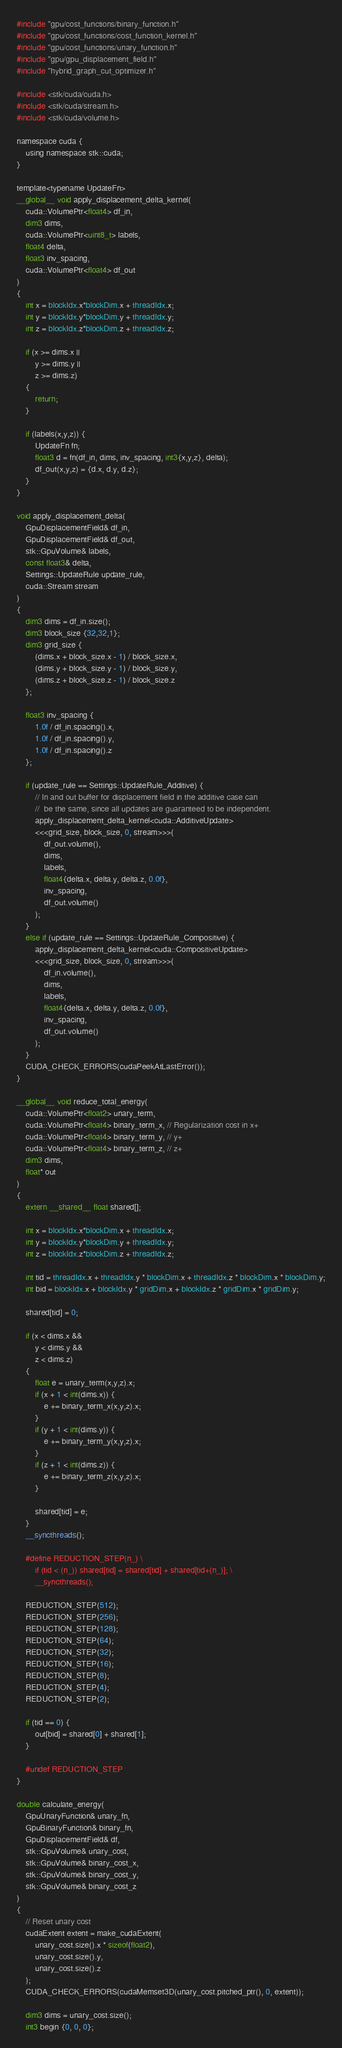Convert code to text. <code><loc_0><loc_0><loc_500><loc_500><_Cuda_>#include "gpu/cost_functions/binary_function.h"
#include "gpu/cost_functions/cost_function_kernel.h"
#include "gpu/cost_functions/unary_function.h"
#include "gpu/gpu_displacement_field.h"
#include "hybrid_graph_cut_optimizer.h"

#include <stk/cuda/cuda.h>
#include <stk/cuda/stream.h>
#include <stk/cuda/volume.h>

namespace cuda {
    using namespace stk::cuda;
}

template<typename UpdateFn>
__global__ void apply_displacement_delta_kernel(
    cuda::VolumePtr<float4> df_in,
    dim3 dims,
    cuda::VolumePtr<uint8_t> labels,
    float4 delta,
    float3 inv_spacing,
    cuda::VolumePtr<float4> df_out
)
{
    int x = blockIdx.x*blockDim.x + threadIdx.x;
    int y = blockIdx.y*blockDim.y + threadIdx.y;
    int z = blockIdx.z*blockDim.z + threadIdx.z;

    if (x >= dims.x ||
        y >= dims.y ||
        z >= dims.z)
    {
        return;
    }

    if (labels(x,y,z)) {
        UpdateFn fn;
        float3 d = fn(df_in, dims, inv_spacing, int3{x,y,z}, delta);
        df_out(x,y,z) = {d.x, d.y, d.z};
    }
}

void apply_displacement_delta(
    GpuDisplacementField& df_in,
    GpuDisplacementField& df_out,
    stk::GpuVolume& labels,
    const float3& delta,
    Settings::UpdateRule update_rule,
    cuda::Stream stream
)
{
    dim3 dims = df_in.size();
    dim3 block_size {32,32,1};
    dim3 grid_size {
        (dims.x + block_size.x - 1) / block_size.x,
        (dims.y + block_size.y - 1) / block_size.y,
        (dims.z + block_size.z - 1) / block_size.z
    };

    float3 inv_spacing {
        1.0f / df_in.spacing().x,
        1.0f / df_in.spacing().y,
        1.0f / df_in.spacing().z
    };

    if (update_rule == Settings::UpdateRule_Additive) {
        // In and out buffer for displacement field in the additive case can 
        //  be the same, since all updates are guaranteed to be independent.
        apply_displacement_delta_kernel<cuda::AdditiveUpdate>
        <<<grid_size, block_size, 0, stream>>>(
            df_out.volume(),
            dims,
            labels,
            float4{delta.x, delta.y, delta.z, 0.0f},
            inv_spacing,
            df_out.volume()
        );
    }
    else if (update_rule == Settings::UpdateRule_Compositive) {
        apply_displacement_delta_kernel<cuda::CompositiveUpdate>
        <<<grid_size, block_size, 0, stream>>>(
            df_in.volume(),
            dims,
            labels,
            float4{delta.x, delta.y, delta.z, 0.0f},
            inv_spacing,
            df_out.volume()
        );
    }
    CUDA_CHECK_ERRORS(cudaPeekAtLastError());
}

__global__ void reduce_total_energy(
    cuda::VolumePtr<float2> unary_term,
    cuda::VolumePtr<float4> binary_term_x, // Regularization cost in x+
    cuda::VolumePtr<float4> binary_term_y, // y+
    cuda::VolumePtr<float4> binary_term_z, // z+
    dim3 dims,
    float* out
)
{
    extern __shared__ float shared[];

    int x = blockIdx.x*blockDim.x + threadIdx.x;
    int y = blockIdx.y*blockDim.y + threadIdx.y;
    int z = blockIdx.z*blockDim.z + threadIdx.z;

    int tid = threadIdx.x + threadIdx.y * blockDim.x + threadIdx.z * blockDim.x * blockDim.y;
    int bid = blockIdx.x + blockIdx.y * gridDim.x + blockIdx.z * gridDim.x * gridDim.y;

    shared[tid] = 0;

    if (x < dims.x &&
        y < dims.y &&
        z < dims.z)
    {
        float e = unary_term(x,y,z).x;
        if (x + 1 < int(dims.x)) {
            e += binary_term_x(x,y,z).x;
        }
        if (y + 1 < int(dims.y)) {
            e += binary_term_y(x,y,z).x;
        }
        if (z + 1 < int(dims.z)) {
            e += binary_term_z(x,y,z).x;
        }

        shared[tid] = e;
    }
    __syncthreads();

    #define REDUCTION_STEP(n_) \
        if (tid < (n_)) shared[tid] = shared[tid] + shared[tid+(n_)]; \
        __syncthreads();

    REDUCTION_STEP(512);
    REDUCTION_STEP(256);
    REDUCTION_STEP(128);
    REDUCTION_STEP(64);
    REDUCTION_STEP(32);
    REDUCTION_STEP(16);
    REDUCTION_STEP(8);
    REDUCTION_STEP(4);
    REDUCTION_STEP(2);

    if (tid == 0) {
        out[bid] = shared[0] + shared[1];
    }

    #undef REDUCTION_STEP
}

double calculate_energy(
    GpuUnaryFunction& unary_fn,
    GpuBinaryFunction& binary_fn,
    GpuDisplacementField& df,
    stk::GpuVolume& unary_cost,
    stk::GpuVolume& binary_cost_x,
    stk::GpuVolume& binary_cost_y,
    stk::GpuVolume& binary_cost_z
)
{
    // Reset unary cost
    cudaExtent extent = make_cudaExtent(
        unary_cost.size().x * sizeof(float2),
        unary_cost.size().y,
        unary_cost.size().z
    );
    CUDA_CHECK_ERRORS(cudaMemset3D(unary_cost.pitched_ptr(), 0, extent));

    dim3 dims = unary_cost.size();
    int3 begin {0, 0, 0};</code> 